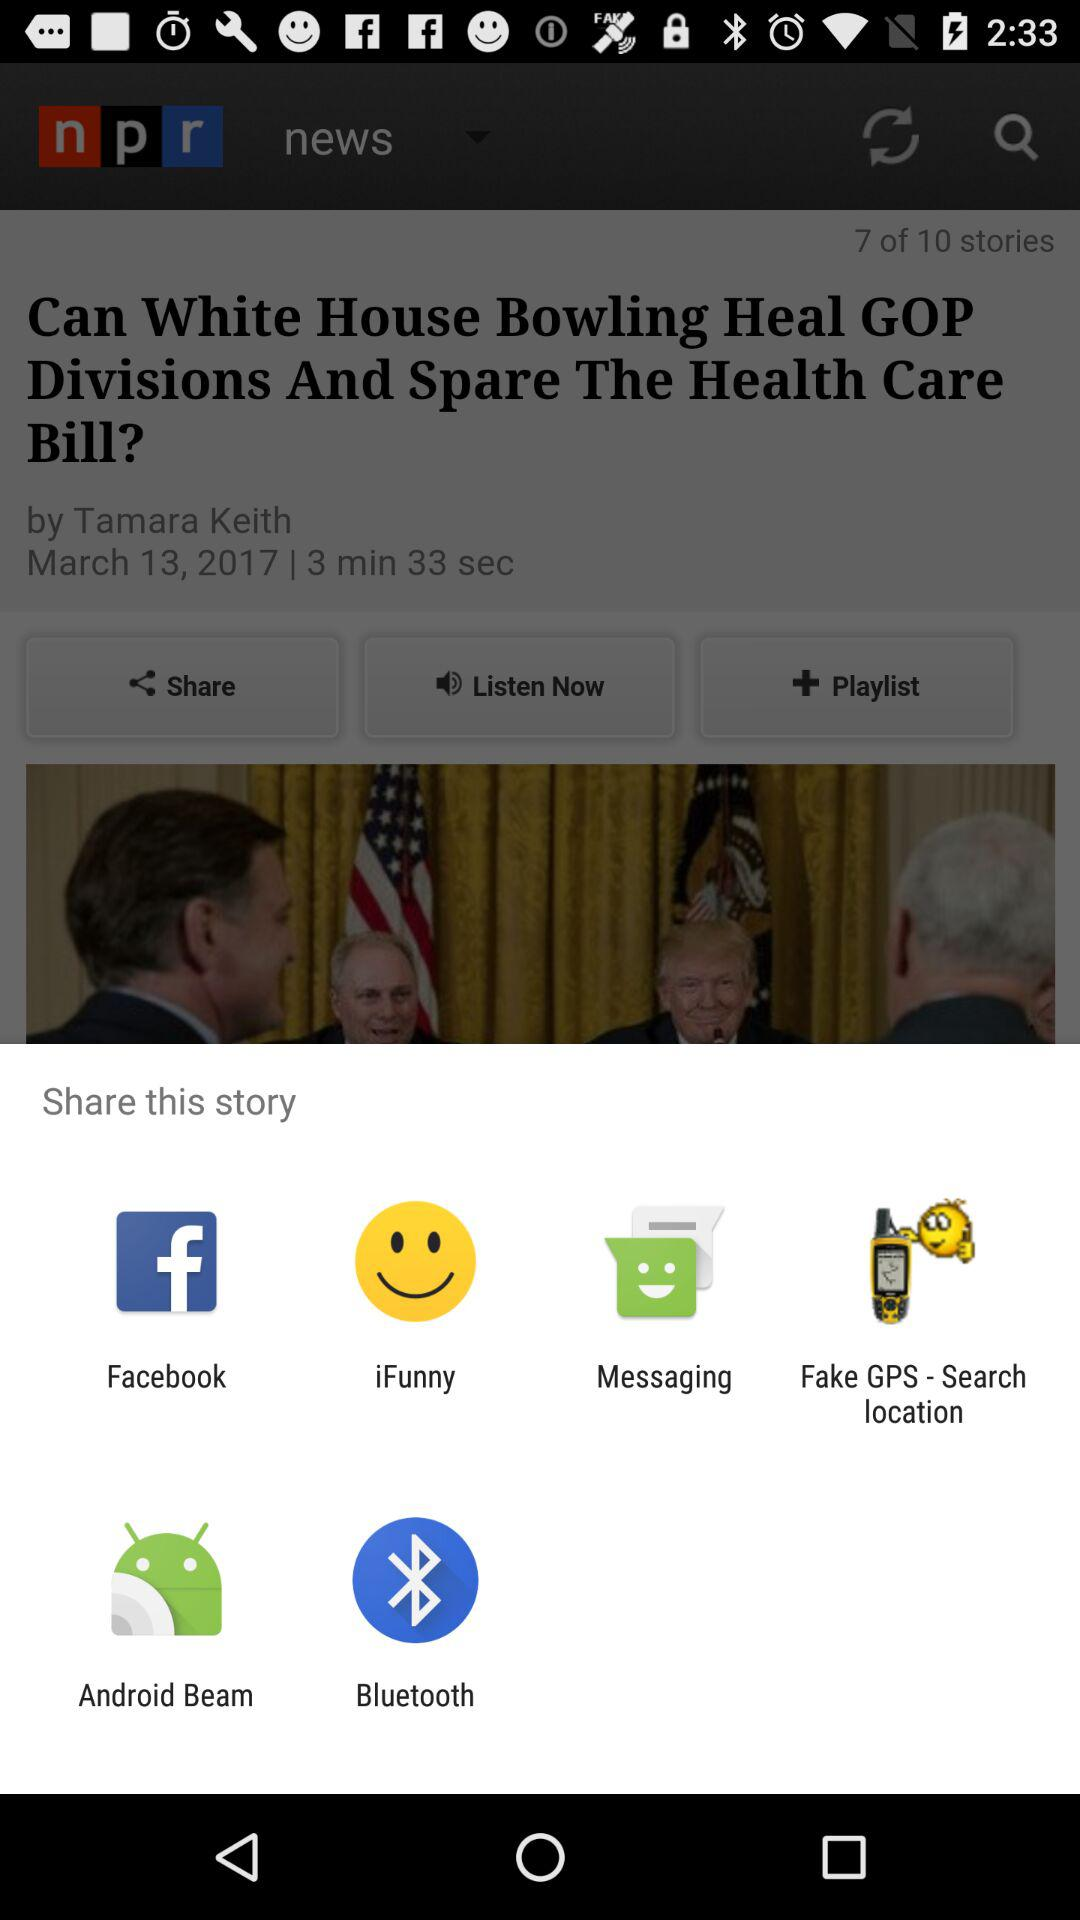What are the different options available to share the story? The different options available to share the story are "Facebook", "iFunny", "Messaging", "Fake GPS - Search location", "Android Beam" and "Bluetooth". 